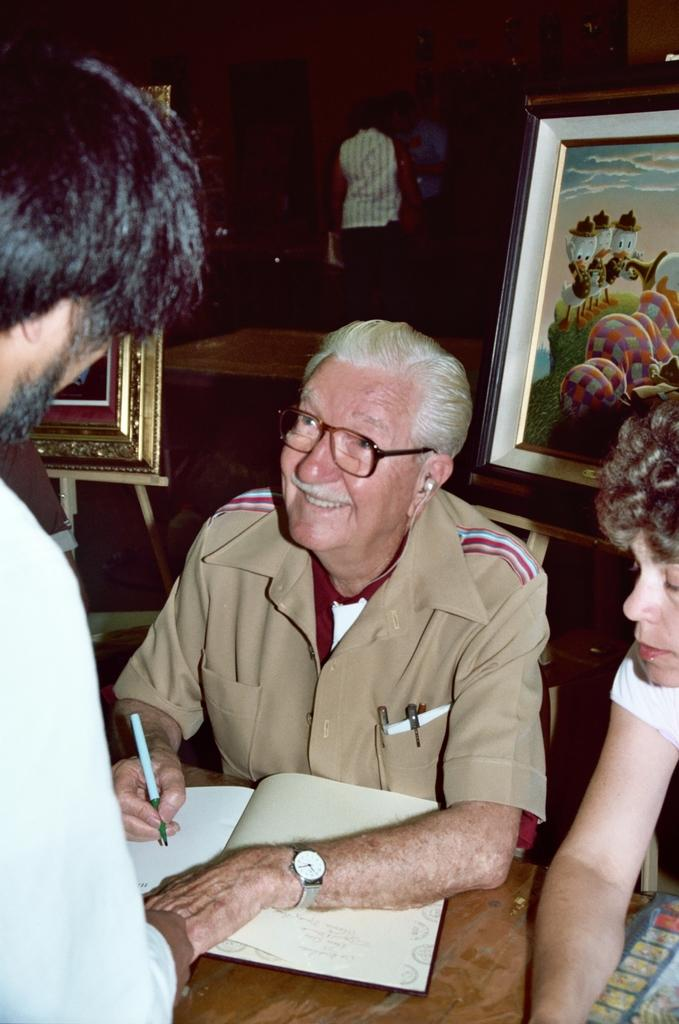How many people are in the image? There are three persons in the image. What objects are in the middle of the image? There is a book and a pen in the middle of the image. What can be seen in the background of the image? There are photo frames and a person standing in the background of the image. What type of guitar is being played by the fairies in the image? There are no fairies or guitars present in the image. How many cherries are on the tree in the image? There is no tree or cherries visible in the image. 